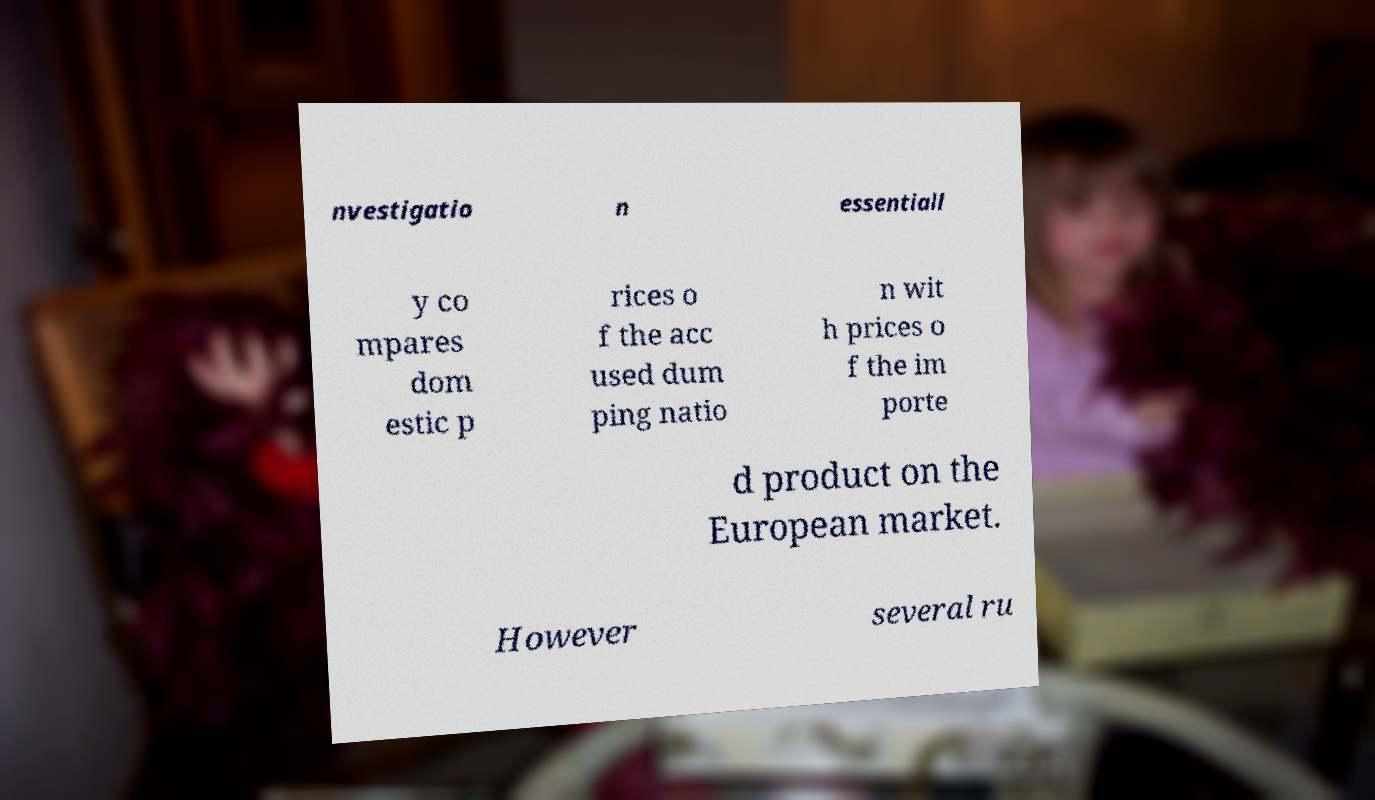For documentation purposes, I need the text within this image transcribed. Could you provide that? nvestigatio n essentiall y co mpares dom estic p rices o f the acc used dum ping natio n wit h prices o f the im porte d product on the European market. However several ru 